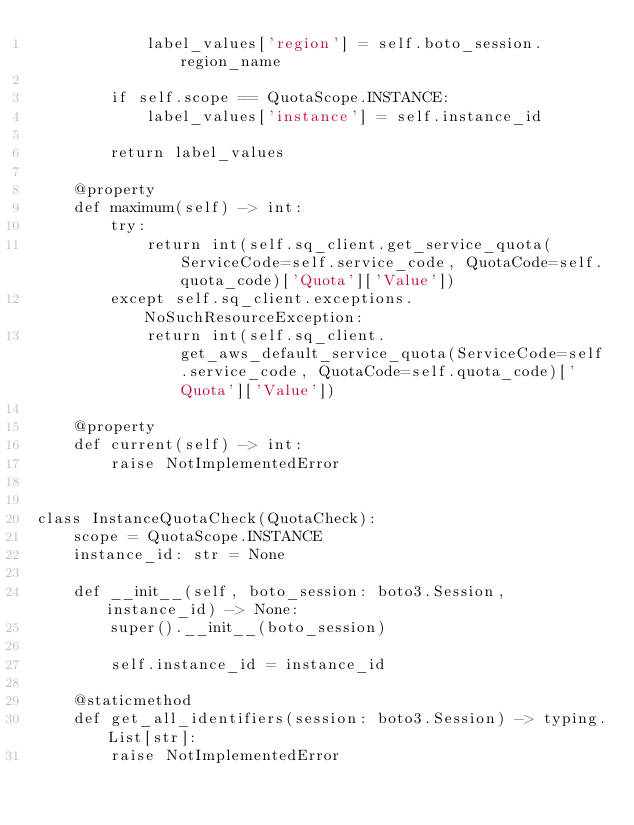<code> <loc_0><loc_0><loc_500><loc_500><_Python_>            label_values['region'] = self.boto_session.region_name

        if self.scope == QuotaScope.INSTANCE:
            label_values['instance'] = self.instance_id

        return label_values

    @property
    def maximum(self) -> int:
        try:
            return int(self.sq_client.get_service_quota(ServiceCode=self.service_code, QuotaCode=self.quota_code)['Quota']['Value'])
        except self.sq_client.exceptions.NoSuchResourceException:
            return int(self.sq_client.get_aws_default_service_quota(ServiceCode=self.service_code, QuotaCode=self.quota_code)['Quota']['Value'])

    @property
    def current(self) -> int:
        raise NotImplementedError


class InstanceQuotaCheck(QuotaCheck):
    scope = QuotaScope.INSTANCE
    instance_id: str = None

    def __init__(self, boto_session: boto3.Session, instance_id) -> None:
        super().__init__(boto_session)

        self.instance_id = instance_id

    @staticmethod
    def get_all_identifiers(session: boto3.Session) -> typing.List[str]:
        raise NotImplementedError
</code> 